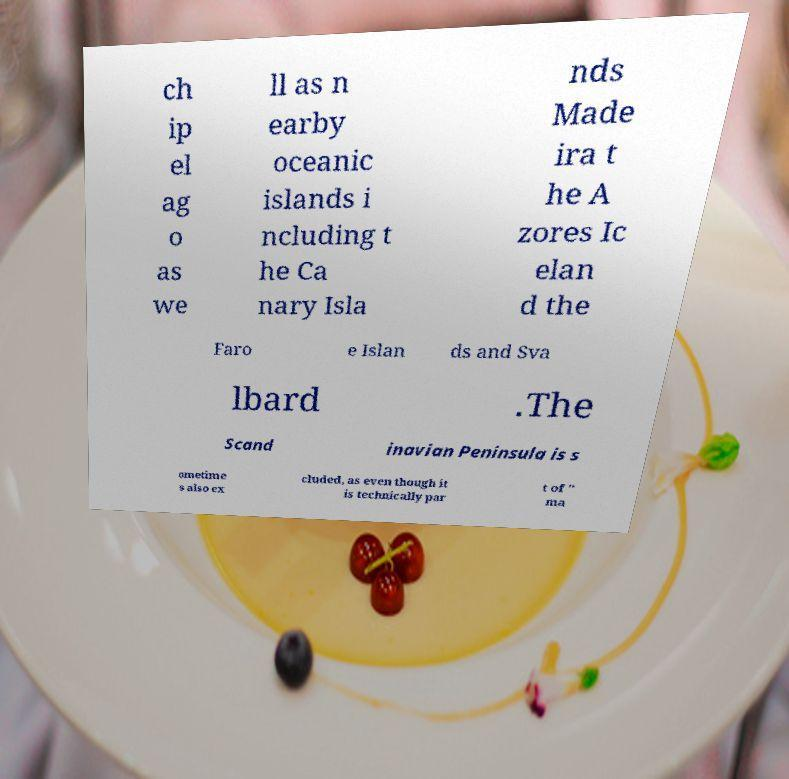For documentation purposes, I need the text within this image transcribed. Could you provide that? ch ip el ag o as we ll as n earby oceanic islands i ncluding t he Ca nary Isla nds Made ira t he A zores Ic elan d the Faro e Islan ds and Sva lbard .The Scand inavian Peninsula is s ometime s also ex cluded, as even though it is technically par t of " ma 